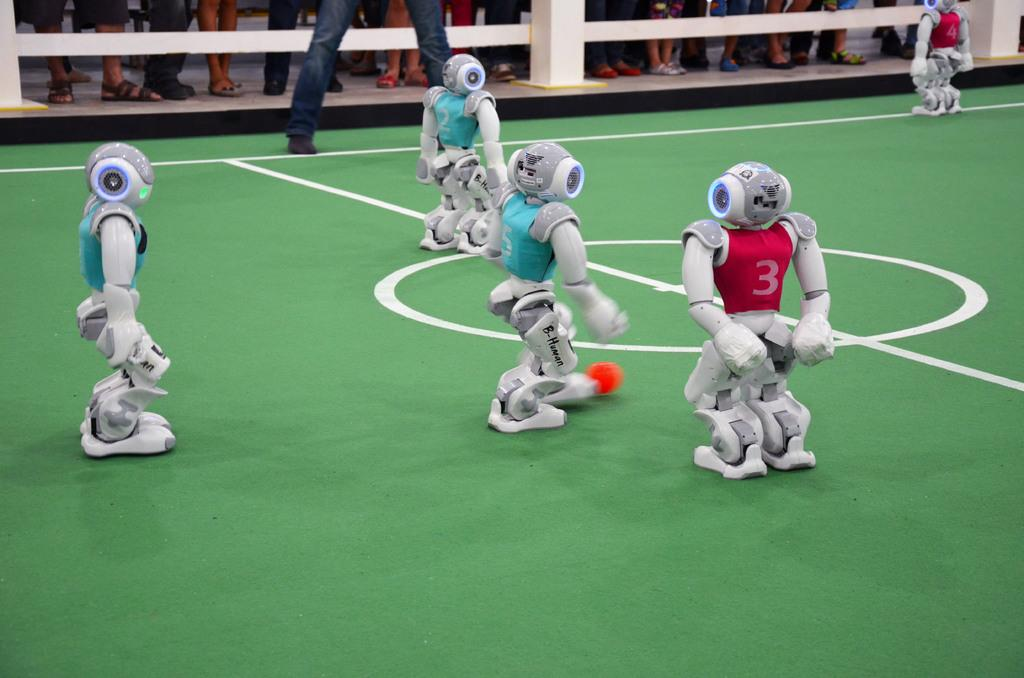Provide a one-sentence caption for the provided image. Several robots, one with a red jersey #3, are playing a game. 